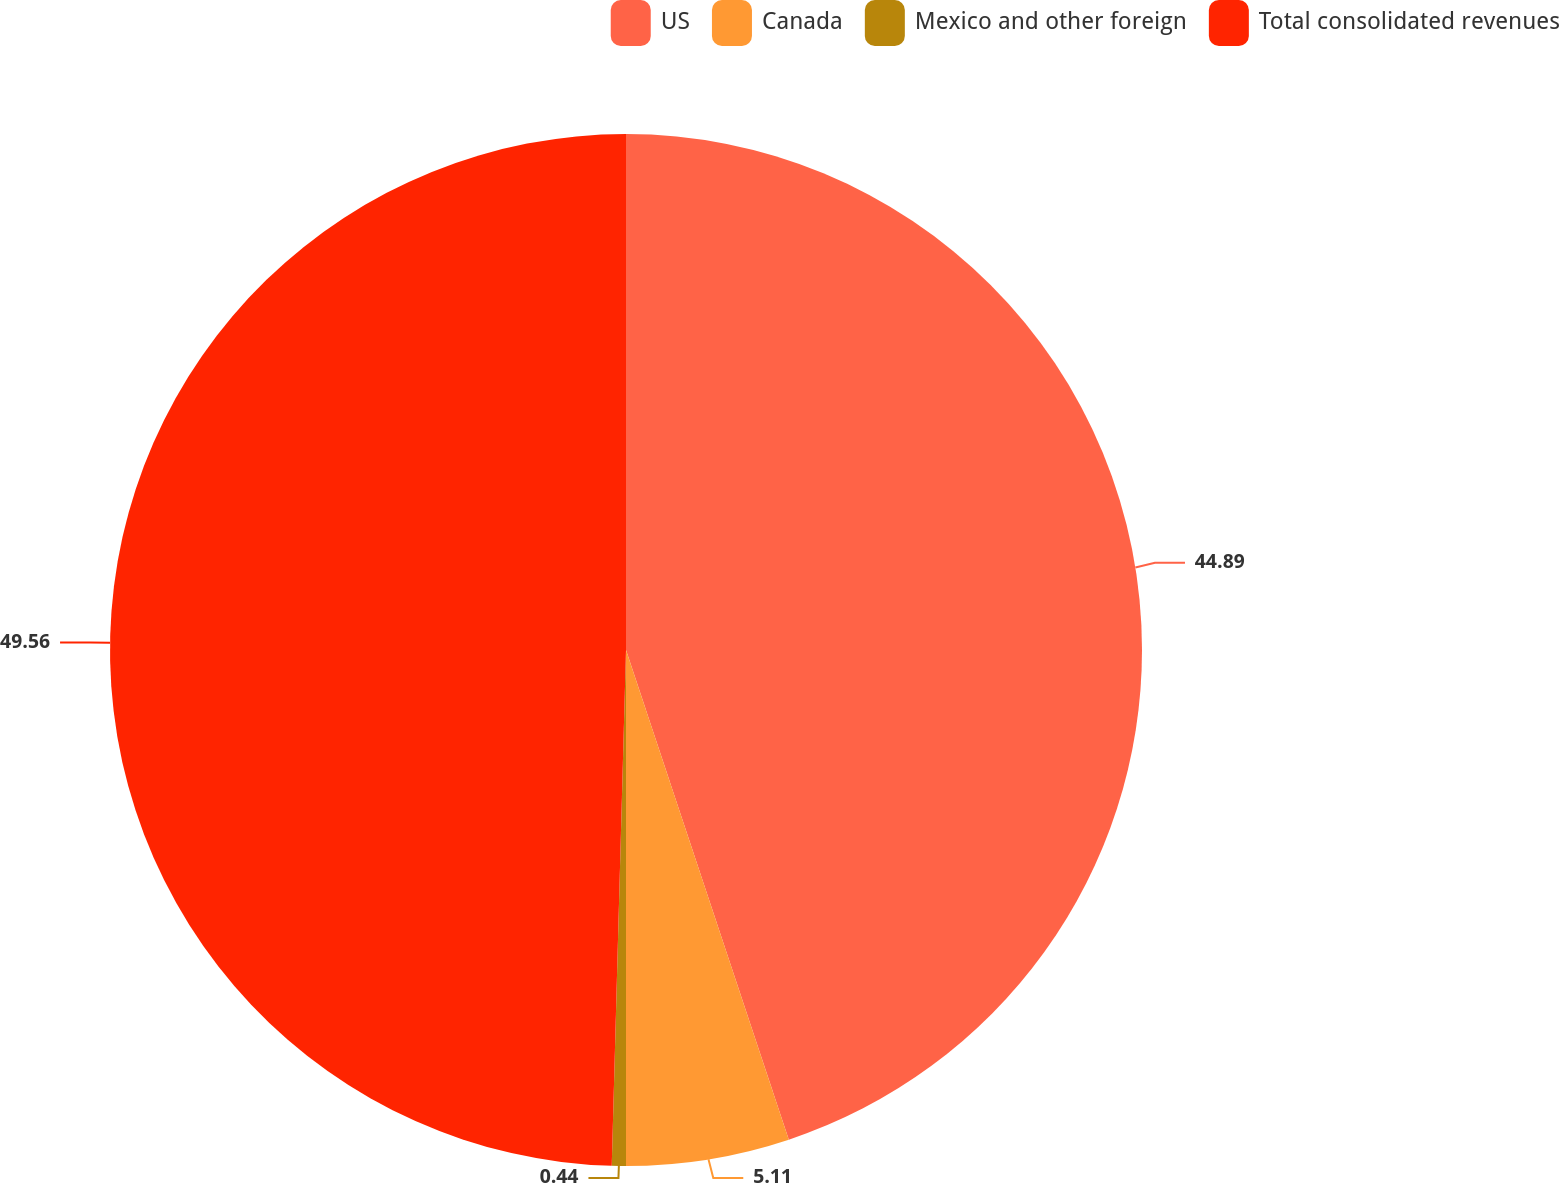<chart> <loc_0><loc_0><loc_500><loc_500><pie_chart><fcel>US<fcel>Canada<fcel>Mexico and other foreign<fcel>Total consolidated revenues<nl><fcel>44.89%<fcel>5.11%<fcel>0.44%<fcel>49.56%<nl></chart> 